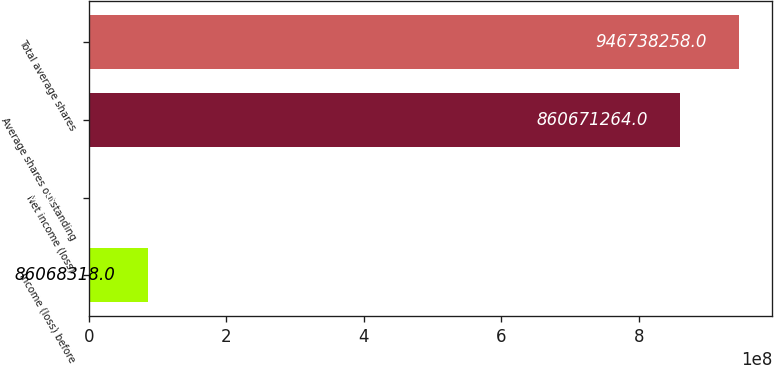Convert chart to OTSL. <chart><loc_0><loc_0><loc_500><loc_500><bar_chart><fcel>Income (loss) before<fcel>Net income (loss)<fcel>Average shares outstanding<fcel>Total average shares<nl><fcel>8.60683e+07<fcel>1324<fcel>8.60671e+08<fcel>9.46738e+08<nl></chart> 